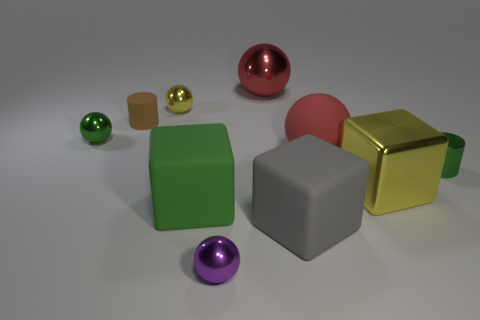Subtract all yellow shiny spheres. How many spheres are left? 4 Subtract all yellow balls. How many balls are left? 4 Subtract all cyan spheres. Subtract all brown cylinders. How many spheres are left? 5 Subtract all cubes. How many objects are left? 7 Add 2 small green metallic cylinders. How many small green metallic cylinders exist? 3 Subtract 1 green blocks. How many objects are left? 9 Subtract all shiny balls. Subtract all tiny green rubber balls. How many objects are left? 6 Add 2 brown rubber objects. How many brown rubber objects are left? 3 